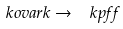<formula> <loc_0><loc_0><loc_500><loc_500>\ k o v a r k \to \ k p f f</formula> 